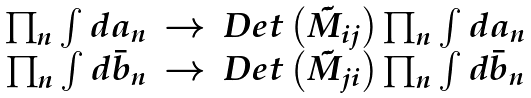<formula> <loc_0><loc_0><loc_500><loc_500>\begin{array} { r c l } \prod _ { n } \int d a _ { n } & \rightarrow & D e t \left ( \tilde { M } _ { i j } \right ) \prod _ { n } \int d a _ { n } \\ \prod _ { n } \int d \bar { b } _ { n } & \rightarrow & D e t \left ( \tilde { M } _ { j i } \right ) \prod _ { n } \int d \bar { b } _ { n } \end{array}</formula> 